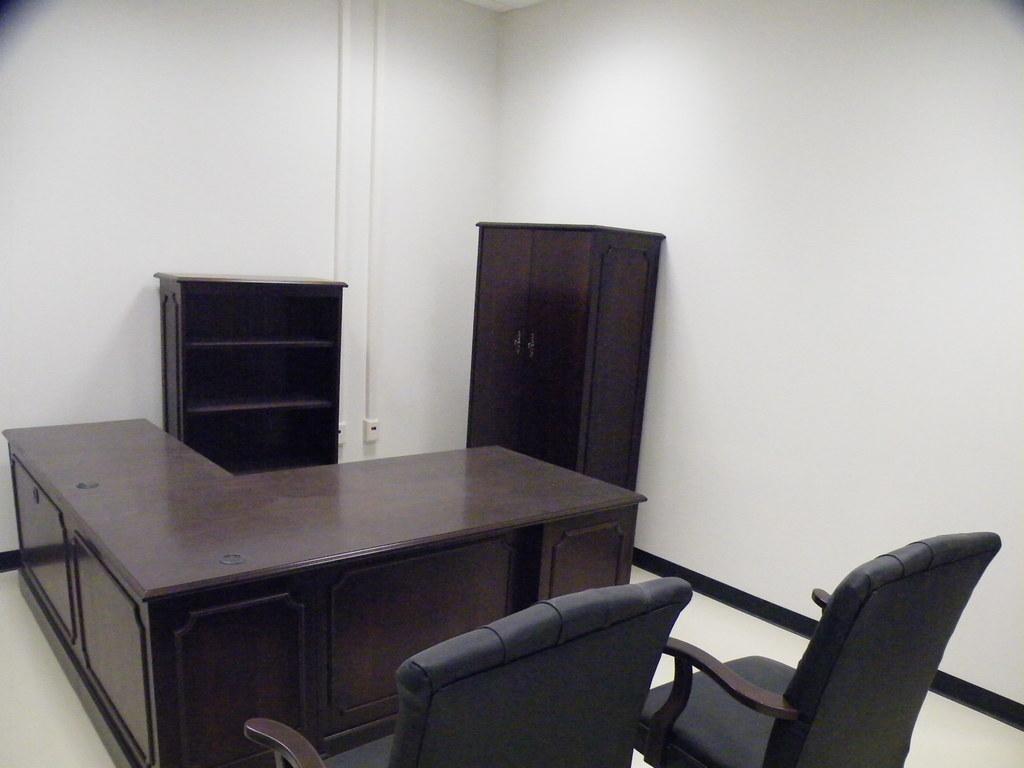Can you describe this image briefly? In this image I can see a table,chair,cupboard and a rack. 